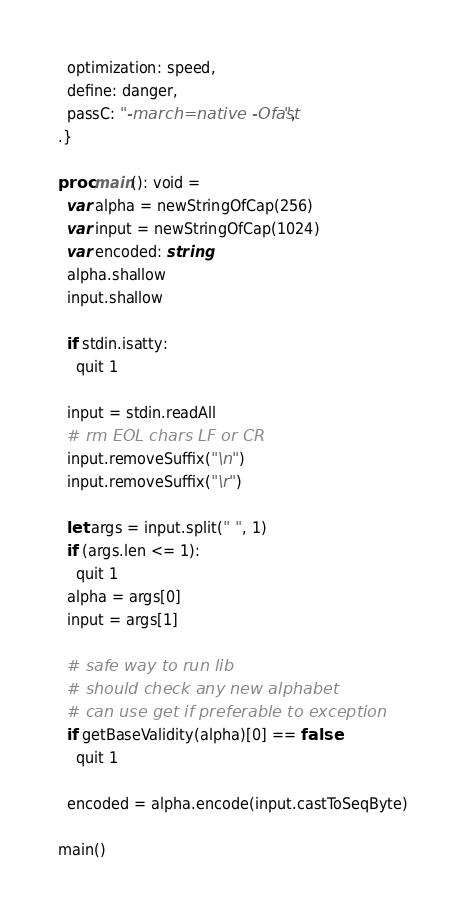Convert code to text. <code><loc_0><loc_0><loc_500><loc_500><_Nim_>  optimization: speed,
  define: danger,
  passC: "-march=native -Ofast",
.}

proc main(): void =
  var alpha = newStringOfCap(256)
  var input = newStringOfCap(1024)
  var encoded: string
  alpha.shallow
  input.shallow

  if stdin.isatty:
    quit 1

  input = stdin.readAll
  # rm EOL chars LF or CR
  input.removeSuffix("\n")
  input.removeSuffix("\r")

  let args = input.split(" ", 1)
  if (args.len <= 1):
    quit 1
  alpha = args[0]
  input = args[1]

  # safe way to run lib
  # should check any new alphabet
  # can use get if preferable to exception
  if getBaseValidity(alpha)[0] == false:
    quit 1

  encoded = alpha.encode(input.castToSeqByte)

main()
</code> 